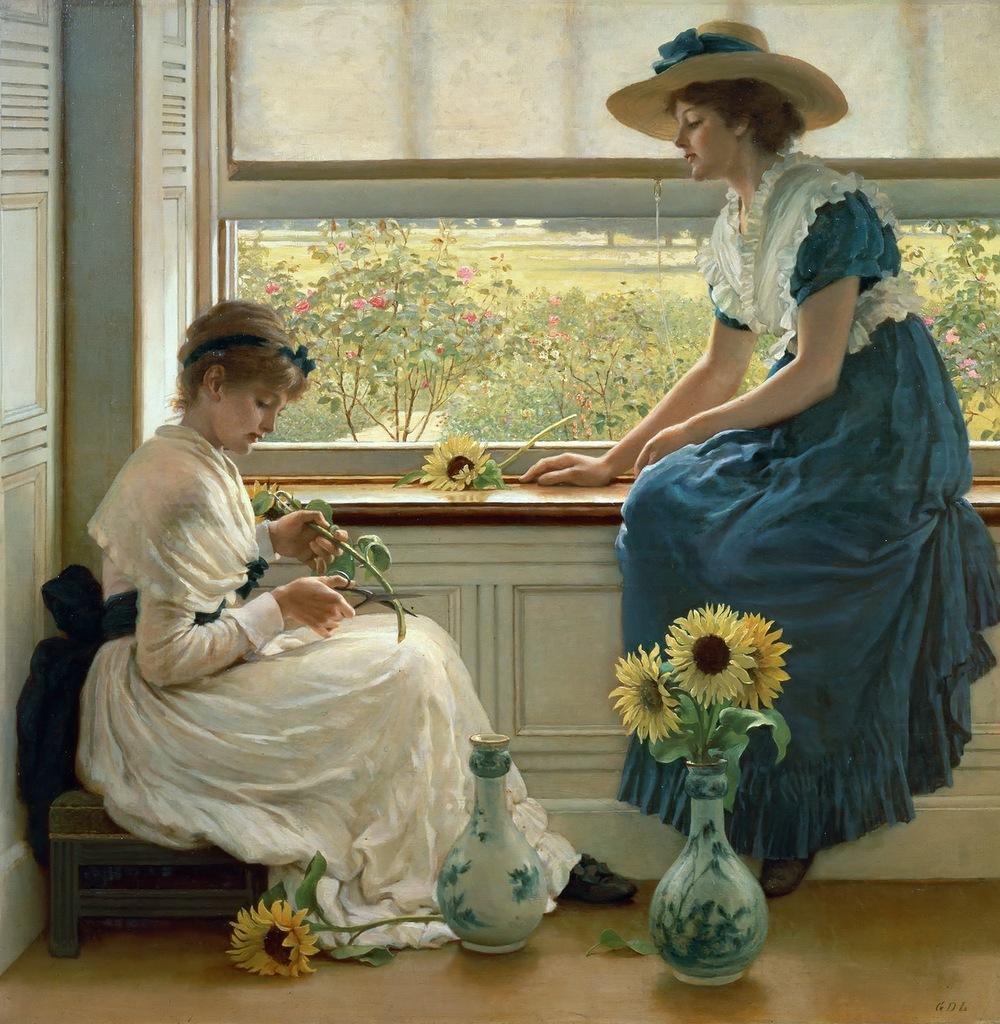Please provide a concise description of this image. In this image we can see a painting. There are two ladies sitting. Lady on the right side is wearing a hat. There are vases. On the vase there are flowers. One lady is holding scissors and a flower with a stem. On the floor there is a flower. And there is a window. Through the window we can see plants and trees. 